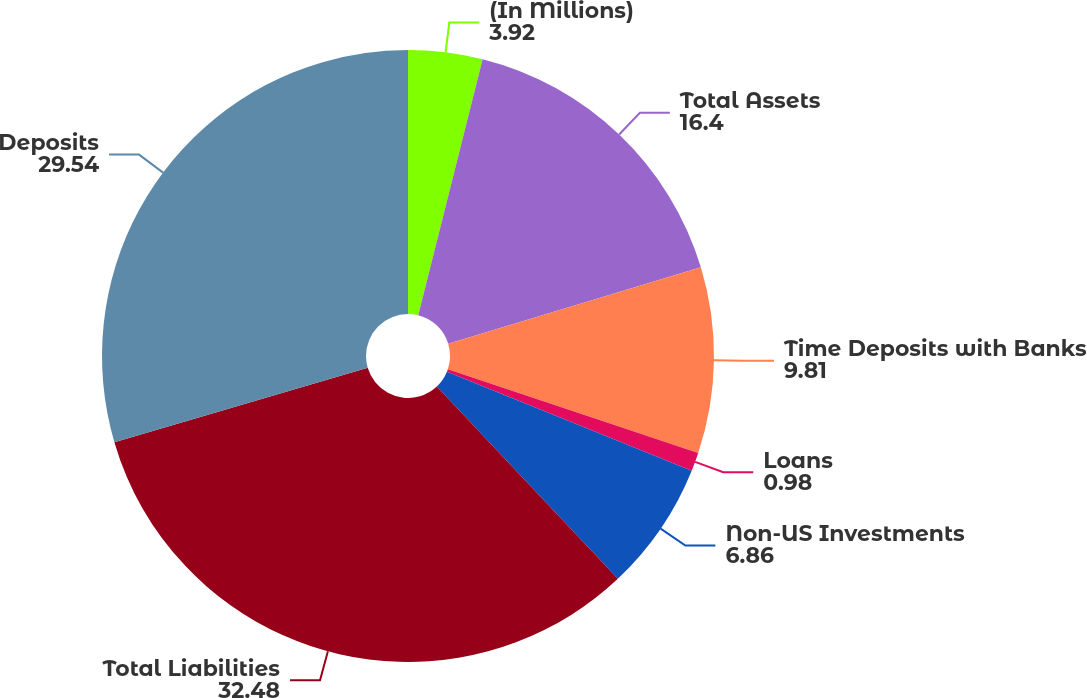Convert chart to OTSL. <chart><loc_0><loc_0><loc_500><loc_500><pie_chart><fcel>(In Millions)<fcel>Total Assets<fcel>Time Deposits with Banks<fcel>Loans<fcel>Non-US Investments<fcel>Total Liabilities<fcel>Deposits<nl><fcel>3.92%<fcel>16.4%<fcel>9.81%<fcel>0.98%<fcel>6.86%<fcel>32.48%<fcel>29.54%<nl></chart> 